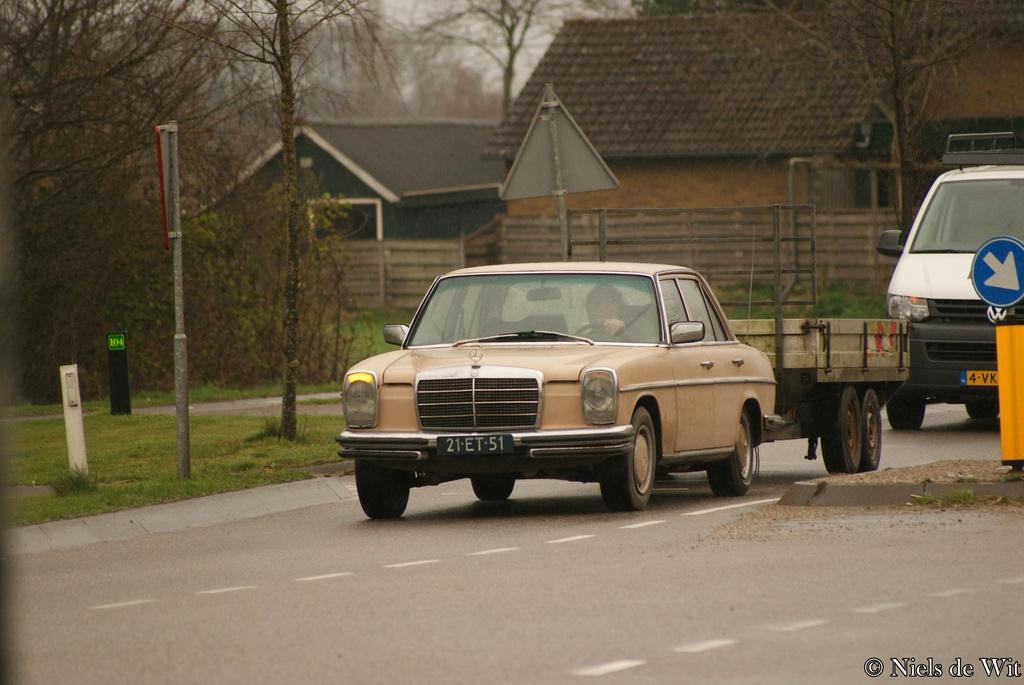Can you describe this image briefly? In this image I can see vehicles are on the road. In the background there are sign boards, trees, houses, fence, grass and rods. On the right side of the image there is a signboard, watermark and logo. 